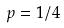<formula> <loc_0><loc_0><loc_500><loc_500>p = 1 / 4</formula> 